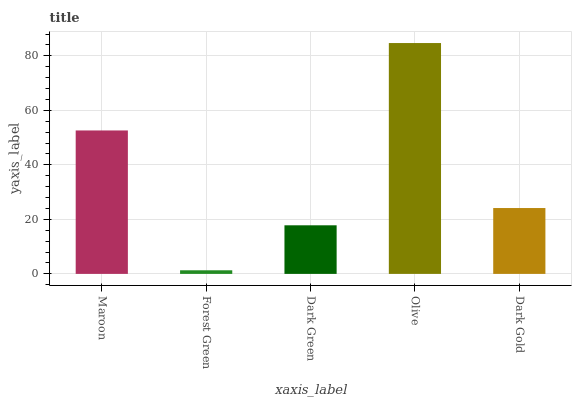Is Forest Green the minimum?
Answer yes or no. Yes. Is Olive the maximum?
Answer yes or no. Yes. Is Dark Green the minimum?
Answer yes or no. No. Is Dark Green the maximum?
Answer yes or no. No. Is Dark Green greater than Forest Green?
Answer yes or no. Yes. Is Forest Green less than Dark Green?
Answer yes or no. Yes. Is Forest Green greater than Dark Green?
Answer yes or no. No. Is Dark Green less than Forest Green?
Answer yes or no. No. Is Dark Gold the high median?
Answer yes or no. Yes. Is Dark Gold the low median?
Answer yes or no. Yes. Is Maroon the high median?
Answer yes or no. No. Is Maroon the low median?
Answer yes or no. No. 